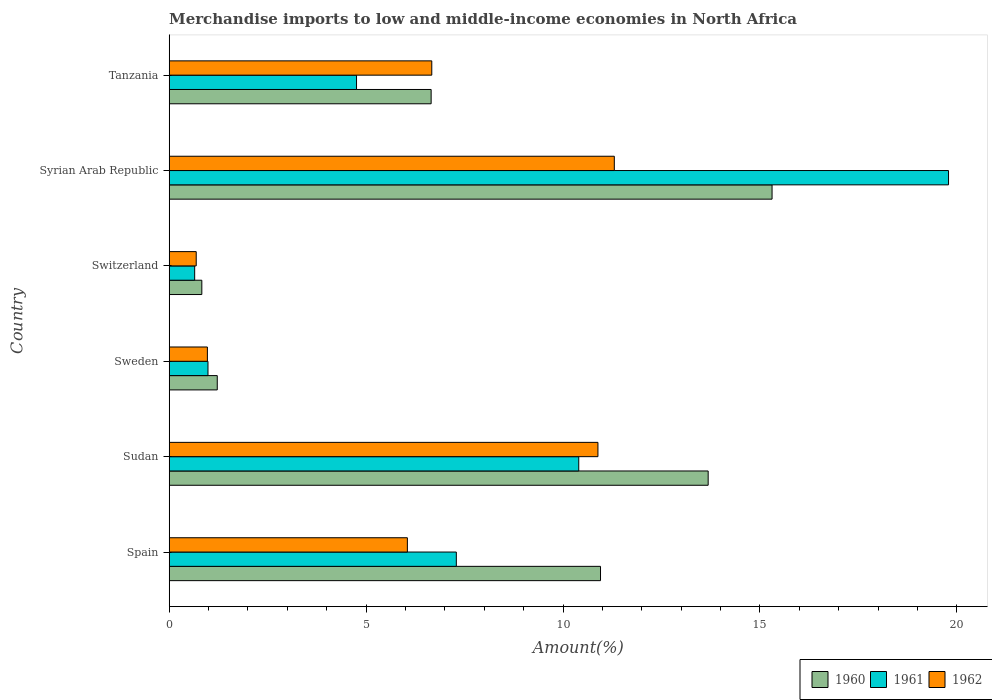How many different coloured bars are there?
Keep it short and to the point. 3. How many groups of bars are there?
Keep it short and to the point. 6. Are the number of bars on each tick of the Y-axis equal?
Provide a short and direct response. Yes. What is the label of the 4th group of bars from the top?
Provide a short and direct response. Sweden. In how many cases, is the number of bars for a given country not equal to the number of legend labels?
Give a very brief answer. 0. What is the percentage of amount earned from merchandise imports in 1960 in Spain?
Provide a short and direct response. 10.95. Across all countries, what is the maximum percentage of amount earned from merchandise imports in 1960?
Your answer should be very brief. 15.31. Across all countries, what is the minimum percentage of amount earned from merchandise imports in 1960?
Your response must be concise. 0.83. In which country was the percentage of amount earned from merchandise imports in 1962 maximum?
Offer a terse response. Syrian Arab Republic. In which country was the percentage of amount earned from merchandise imports in 1961 minimum?
Offer a very short reply. Switzerland. What is the total percentage of amount earned from merchandise imports in 1960 in the graph?
Your response must be concise. 48.64. What is the difference between the percentage of amount earned from merchandise imports in 1961 in Sweden and that in Tanzania?
Provide a short and direct response. -3.77. What is the difference between the percentage of amount earned from merchandise imports in 1960 in Spain and the percentage of amount earned from merchandise imports in 1961 in Tanzania?
Make the answer very short. 6.19. What is the average percentage of amount earned from merchandise imports in 1960 per country?
Your response must be concise. 8.11. What is the difference between the percentage of amount earned from merchandise imports in 1962 and percentage of amount earned from merchandise imports in 1960 in Sudan?
Give a very brief answer. -2.8. In how many countries, is the percentage of amount earned from merchandise imports in 1961 greater than 12 %?
Your answer should be very brief. 1. What is the ratio of the percentage of amount earned from merchandise imports in 1961 in Syrian Arab Republic to that in Tanzania?
Your answer should be very brief. 4.16. Is the percentage of amount earned from merchandise imports in 1961 in Spain less than that in Tanzania?
Your answer should be compact. No. Is the difference between the percentage of amount earned from merchandise imports in 1962 in Sudan and Switzerland greater than the difference between the percentage of amount earned from merchandise imports in 1960 in Sudan and Switzerland?
Keep it short and to the point. No. What is the difference between the highest and the second highest percentage of amount earned from merchandise imports in 1960?
Ensure brevity in your answer.  1.62. What is the difference between the highest and the lowest percentage of amount earned from merchandise imports in 1962?
Keep it short and to the point. 10.62. In how many countries, is the percentage of amount earned from merchandise imports in 1960 greater than the average percentage of amount earned from merchandise imports in 1960 taken over all countries?
Your answer should be very brief. 3. Is the sum of the percentage of amount earned from merchandise imports in 1962 in Switzerland and Syrian Arab Republic greater than the maximum percentage of amount earned from merchandise imports in 1961 across all countries?
Ensure brevity in your answer.  No. Is it the case that in every country, the sum of the percentage of amount earned from merchandise imports in 1962 and percentage of amount earned from merchandise imports in 1960 is greater than the percentage of amount earned from merchandise imports in 1961?
Offer a very short reply. Yes. What is the difference between two consecutive major ticks on the X-axis?
Your response must be concise. 5. Are the values on the major ticks of X-axis written in scientific E-notation?
Provide a succinct answer. No. Does the graph contain any zero values?
Make the answer very short. No. Does the graph contain grids?
Your answer should be compact. No. Where does the legend appear in the graph?
Your response must be concise. Bottom right. How are the legend labels stacked?
Your answer should be very brief. Horizontal. What is the title of the graph?
Offer a very short reply. Merchandise imports to low and middle-income economies in North Africa. What is the label or title of the X-axis?
Your response must be concise. Amount(%). What is the Amount(%) in 1960 in Spain?
Provide a short and direct response. 10.95. What is the Amount(%) in 1961 in Spain?
Your answer should be very brief. 7.29. What is the Amount(%) in 1962 in Spain?
Your response must be concise. 6.05. What is the Amount(%) of 1960 in Sudan?
Your answer should be very brief. 13.68. What is the Amount(%) in 1961 in Sudan?
Offer a very short reply. 10.4. What is the Amount(%) in 1962 in Sudan?
Your response must be concise. 10.89. What is the Amount(%) in 1960 in Sweden?
Your answer should be compact. 1.22. What is the Amount(%) of 1961 in Sweden?
Provide a succinct answer. 0.98. What is the Amount(%) in 1962 in Sweden?
Offer a terse response. 0.97. What is the Amount(%) of 1960 in Switzerland?
Provide a succinct answer. 0.83. What is the Amount(%) in 1961 in Switzerland?
Offer a terse response. 0.65. What is the Amount(%) in 1962 in Switzerland?
Offer a very short reply. 0.69. What is the Amount(%) of 1960 in Syrian Arab Republic?
Your response must be concise. 15.31. What is the Amount(%) in 1961 in Syrian Arab Republic?
Provide a short and direct response. 19.79. What is the Amount(%) in 1962 in Syrian Arab Republic?
Your response must be concise. 11.3. What is the Amount(%) in 1960 in Tanzania?
Your answer should be very brief. 6.65. What is the Amount(%) of 1961 in Tanzania?
Ensure brevity in your answer.  4.76. What is the Amount(%) in 1962 in Tanzania?
Give a very brief answer. 6.67. Across all countries, what is the maximum Amount(%) in 1960?
Your answer should be very brief. 15.31. Across all countries, what is the maximum Amount(%) of 1961?
Make the answer very short. 19.79. Across all countries, what is the maximum Amount(%) in 1962?
Offer a very short reply. 11.3. Across all countries, what is the minimum Amount(%) of 1960?
Ensure brevity in your answer.  0.83. Across all countries, what is the minimum Amount(%) of 1961?
Your response must be concise. 0.65. Across all countries, what is the minimum Amount(%) in 1962?
Your answer should be compact. 0.69. What is the total Amount(%) of 1960 in the graph?
Keep it short and to the point. 48.64. What is the total Amount(%) of 1961 in the graph?
Ensure brevity in your answer.  43.86. What is the total Amount(%) in 1962 in the graph?
Provide a short and direct response. 36.56. What is the difference between the Amount(%) of 1960 in Spain and that in Sudan?
Your answer should be very brief. -2.73. What is the difference between the Amount(%) in 1961 in Spain and that in Sudan?
Give a very brief answer. -3.11. What is the difference between the Amount(%) in 1962 in Spain and that in Sudan?
Your response must be concise. -4.84. What is the difference between the Amount(%) of 1960 in Spain and that in Sweden?
Offer a very short reply. 9.73. What is the difference between the Amount(%) in 1961 in Spain and that in Sweden?
Offer a very short reply. 6.31. What is the difference between the Amount(%) of 1962 in Spain and that in Sweden?
Your answer should be very brief. 5.08. What is the difference between the Amount(%) in 1960 in Spain and that in Switzerland?
Your answer should be very brief. 10.12. What is the difference between the Amount(%) of 1961 in Spain and that in Switzerland?
Provide a succinct answer. 6.64. What is the difference between the Amount(%) of 1962 in Spain and that in Switzerland?
Keep it short and to the point. 5.36. What is the difference between the Amount(%) in 1960 in Spain and that in Syrian Arab Republic?
Give a very brief answer. -4.36. What is the difference between the Amount(%) in 1961 in Spain and that in Syrian Arab Republic?
Provide a succinct answer. -12.5. What is the difference between the Amount(%) of 1962 in Spain and that in Syrian Arab Republic?
Offer a terse response. -5.25. What is the difference between the Amount(%) in 1960 in Spain and that in Tanzania?
Provide a short and direct response. 4.3. What is the difference between the Amount(%) of 1961 in Spain and that in Tanzania?
Your answer should be very brief. 2.53. What is the difference between the Amount(%) in 1962 in Spain and that in Tanzania?
Provide a short and direct response. -0.62. What is the difference between the Amount(%) of 1960 in Sudan and that in Sweden?
Offer a very short reply. 12.46. What is the difference between the Amount(%) in 1961 in Sudan and that in Sweden?
Keep it short and to the point. 9.41. What is the difference between the Amount(%) of 1962 in Sudan and that in Sweden?
Provide a succinct answer. 9.92. What is the difference between the Amount(%) of 1960 in Sudan and that in Switzerland?
Your answer should be very brief. 12.86. What is the difference between the Amount(%) in 1961 in Sudan and that in Switzerland?
Offer a very short reply. 9.75. What is the difference between the Amount(%) of 1962 in Sudan and that in Switzerland?
Your answer should be very brief. 10.2. What is the difference between the Amount(%) of 1960 in Sudan and that in Syrian Arab Republic?
Give a very brief answer. -1.62. What is the difference between the Amount(%) of 1961 in Sudan and that in Syrian Arab Republic?
Give a very brief answer. -9.39. What is the difference between the Amount(%) of 1962 in Sudan and that in Syrian Arab Republic?
Keep it short and to the point. -0.42. What is the difference between the Amount(%) in 1960 in Sudan and that in Tanzania?
Offer a very short reply. 7.03. What is the difference between the Amount(%) of 1961 in Sudan and that in Tanzania?
Your answer should be very brief. 5.64. What is the difference between the Amount(%) of 1962 in Sudan and that in Tanzania?
Your response must be concise. 4.22. What is the difference between the Amount(%) of 1960 in Sweden and that in Switzerland?
Make the answer very short. 0.39. What is the difference between the Amount(%) in 1961 in Sweden and that in Switzerland?
Keep it short and to the point. 0.34. What is the difference between the Amount(%) in 1962 in Sweden and that in Switzerland?
Offer a very short reply. 0.28. What is the difference between the Amount(%) of 1960 in Sweden and that in Syrian Arab Republic?
Provide a succinct answer. -14.09. What is the difference between the Amount(%) in 1961 in Sweden and that in Syrian Arab Republic?
Your response must be concise. -18.8. What is the difference between the Amount(%) of 1962 in Sweden and that in Syrian Arab Republic?
Ensure brevity in your answer.  -10.33. What is the difference between the Amount(%) in 1960 in Sweden and that in Tanzania?
Ensure brevity in your answer.  -5.43. What is the difference between the Amount(%) of 1961 in Sweden and that in Tanzania?
Provide a short and direct response. -3.77. What is the difference between the Amount(%) in 1962 in Sweden and that in Tanzania?
Keep it short and to the point. -5.7. What is the difference between the Amount(%) of 1960 in Switzerland and that in Syrian Arab Republic?
Provide a succinct answer. -14.48. What is the difference between the Amount(%) of 1961 in Switzerland and that in Syrian Arab Republic?
Ensure brevity in your answer.  -19.14. What is the difference between the Amount(%) in 1962 in Switzerland and that in Syrian Arab Republic?
Your answer should be very brief. -10.62. What is the difference between the Amount(%) of 1960 in Switzerland and that in Tanzania?
Provide a succinct answer. -5.82. What is the difference between the Amount(%) of 1961 in Switzerland and that in Tanzania?
Provide a succinct answer. -4.11. What is the difference between the Amount(%) of 1962 in Switzerland and that in Tanzania?
Offer a very short reply. -5.98. What is the difference between the Amount(%) of 1960 in Syrian Arab Republic and that in Tanzania?
Provide a short and direct response. 8.66. What is the difference between the Amount(%) in 1961 in Syrian Arab Republic and that in Tanzania?
Offer a terse response. 15.03. What is the difference between the Amount(%) in 1962 in Syrian Arab Republic and that in Tanzania?
Keep it short and to the point. 4.63. What is the difference between the Amount(%) in 1960 in Spain and the Amount(%) in 1961 in Sudan?
Ensure brevity in your answer.  0.55. What is the difference between the Amount(%) of 1960 in Spain and the Amount(%) of 1962 in Sudan?
Offer a terse response. 0.07. What is the difference between the Amount(%) in 1961 in Spain and the Amount(%) in 1962 in Sudan?
Provide a succinct answer. -3.6. What is the difference between the Amount(%) in 1960 in Spain and the Amount(%) in 1961 in Sweden?
Ensure brevity in your answer.  9.97. What is the difference between the Amount(%) of 1960 in Spain and the Amount(%) of 1962 in Sweden?
Give a very brief answer. 9.98. What is the difference between the Amount(%) of 1961 in Spain and the Amount(%) of 1962 in Sweden?
Keep it short and to the point. 6.32. What is the difference between the Amount(%) of 1960 in Spain and the Amount(%) of 1961 in Switzerland?
Provide a short and direct response. 10.3. What is the difference between the Amount(%) of 1960 in Spain and the Amount(%) of 1962 in Switzerland?
Ensure brevity in your answer.  10.27. What is the difference between the Amount(%) of 1961 in Spain and the Amount(%) of 1962 in Switzerland?
Offer a very short reply. 6.6. What is the difference between the Amount(%) of 1960 in Spain and the Amount(%) of 1961 in Syrian Arab Republic?
Your response must be concise. -8.84. What is the difference between the Amount(%) of 1960 in Spain and the Amount(%) of 1962 in Syrian Arab Republic?
Give a very brief answer. -0.35. What is the difference between the Amount(%) in 1961 in Spain and the Amount(%) in 1962 in Syrian Arab Republic?
Your answer should be very brief. -4.01. What is the difference between the Amount(%) in 1960 in Spain and the Amount(%) in 1961 in Tanzania?
Your answer should be compact. 6.19. What is the difference between the Amount(%) of 1960 in Spain and the Amount(%) of 1962 in Tanzania?
Ensure brevity in your answer.  4.28. What is the difference between the Amount(%) of 1961 in Spain and the Amount(%) of 1962 in Tanzania?
Offer a very short reply. 0.62. What is the difference between the Amount(%) in 1960 in Sudan and the Amount(%) in 1961 in Sweden?
Provide a short and direct response. 12.7. What is the difference between the Amount(%) in 1960 in Sudan and the Amount(%) in 1962 in Sweden?
Your response must be concise. 12.71. What is the difference between the Amount(%) in 1961 in Sudan and the Amount(%) in 1962 in Sweden?
Offer a terse response. 9.43. What is the difference between the Amount(%) in 1960 in Sudan and the Amount(%) in 1961 in Switzerland?
Your answer should be compact. 13.04. What is the difference between the Amount(%) in 1960 in Sudan and the Amount(%) in 1962 in Switzerland?
Give a very brief answer. 13. What is the difference between the Amount(%) in 1961 in Sudan and the Amount(%) in 1962 in Switzerland?
Offer a terse response. 9.71. What is the difference between the Amount(%) of 1960 in Sudan and the Amount(%) of 1961 in Syrian Arab Republic?
Your response must be concise. -6.1. What is the difference between the Amount(%) in 1960 in Sudan and the Amount(%) in 1962 in Syrian Arab Republic?
Make the answer very short. 2.38. What is the difference between the Amount(%) in 1961 in Sudan and the Amount(%) in 1962 in Syrian Arab Republic?
Offer a very short reply. -0.9. What is the difference between the Amount(%) in 1960 in Sudan and the Amount(%) in 1961 in Tanzania?
Your answer should be compact. 8.93. What is the difference between the Amount(%) in 1960 in Sudan and the Amount(%) in 1962 in Tanzania?
Provide a succinct answer. 7.02. What is the difference between the Amount(%) of 1961 in Sudan and the Amount(%) of 1962 in Tanzania?
Your answer should be very brief. 3.73. What is the difference between the Amount(%) in 1960 in Sweden and the Amount(%) in 1961 in Switzerland?
Ensure brevity in your answer.  0.57. What is the difference between the Amount(%) of 1960 in Sweden and the Amount(%) of 1962 in Switzerland?
Keep it short and to the point. 0.53. What is the difference between the Amount(%) of 1961 in Sweden and the Amount(%) of 1962 in Switzerland?
Offer a very short reply. 0.3. What is the difference between the Amount(%) in 1960 in Sweden and the Amount(%) in 1961 in Syrian Arab Republic?
Ensure brevity in your answer.  -18.57. What is the difference between the Amount(%) in 1960 in Sweden and the Amount(%) in 1962 in Syrian Arab Republic?
Ensure brevity in your answer.  -10.08. What is the difference between the Amount(%) of 1961 in Sweden and the Amount(%) of 1962 in Syrian Arab Republic?
Keep it short and to the point. -10.32. What is the difference between the Amount(%) of 1960 in Sweden and the Amount(%) of 1961 in Tanzania?
Keep it short and to the point. -3.54. What is the difference between the Amount(%) of 1960 in Sweden and the Amount(%) of 1962 in Tanzania?
Keep it short and to the point. -5.45. What is the difference between the Amount(%) of 1961 in Sweden and the Amount(%) of 1962 in Tanzania?
Your response must be concise. -5.68. What is the difference between the Amount(%) in 1960 in Switzerland and the Amount(%) in 1961 in Syrian Arab Republic?
Your answer should be compact. -18.96. What is the difference between the Amount(%) of 1960 in Switzerland and the Amount(%) of 1962 in Syrian Arab Republic?
Offer a terse response. -10.47. What is the difference between the Amount(%) of 1961 in Switzerland and the Amount(%) of 1962 in Syrian Arab Republic?
Keep it short and to the point. -10.65. What is the difference between the Amount(%) in 1960 in Switzerland and the Amount(%) in 1961 in Tanzania?
Ensure brevity in your answer.  -3.93. What is the difference between the Amount(%) of 1960 in Switzerland and the Amount(%) of 1962 in Tanzania?
Keep it short and to the point. -5.84. What is the difference between the Amount(%) of 1961 in Switzerland and the Amount(%) of 1962 in Tanzania?
Your answer should be very brief. -6.02. What is the difference between the Amount(%) of 1960 in Syrian Arab Republic and the Amount(%) of 1961 in Tanzania?
Make the answer very short. 10.55. What is the difference between the Amount(%) of 1960 in Syrian Arab Republic and the Amount(%) of 1962 in Tanzania?
Keep it short and to the point. 8.64. What is the difference between the Amount(%) in 1961 in Syrian Arab Republic and the Amount(%) in 1962 in Tanzania?
Ensure brevity in your answer.  13.12. What is the average Amount(%) in 1960 per country?
Your answer should be very brief. 8.11. What is the average Amount(%) in 1961 per country?
Offer a very short reply. 7.31. What is the average Amount(%) of 1962 per country?
Your response must be concise. 6.09. What is the difference between the Amount(%) of 1960 and Amount(%) of 1961 in Spain?
Your answer should be compact. 3.66. What is the difference between the Amount(%) in 1960 and Amount(%) in 1962 in Spain?
Offer a terse response. 4.9. What is the difference between the Amount(%) in 1961 and Amount(%) in 1962 in Spain?
Offer a very short reply. 1.24. What is the difference between the Amount(%) in 1960 and Amount(%) in 1961 in Sudan?
Your answer should be very brief. 3.29. What is the difference between the Amount(%) in 1960 and Amount(%) in 1962 in Sudan?
Give a very brief answer. 2.8. What is the difference between the Amount(%) in 1961 and Amount(%) in 1962 in Sudan?
Make the answer very short. -0.49. What is the difference between the Amount(%) in 1960 and Amount(%) in 1961 in Sweden?
Ensure brevity in your answer.  0.24. What is the difference between the Amount(%) in 1960 and Amount(%) in 1962 in Sweden?
Make the answer very short. 0.25. What is the difference between the Amount(%) in 1961 and Amount(%) in 1962 in Sweden?
Offer a terse response. 0.02. What is the difference between the Amount(%) of 1960 and Amount(%) of 1961 in Switzerland?
Your answer should be very brief. 0.18. What is the difference between the Amount(%) of 1960 and Amount(%) of 1962 in Switzerland?
Keep it short and to the point. 0.14. What is the difference between the Amount(%) of 1961 and Amount(%) of 1962 in Switzerland?
Your response must be concise. -0.04. What is the difference between the Amount(%) in 1960 and Amount(%) in 1961 in Syrian Arab Republic?
Provide a succinct answer. -4.48. What is the difference between the Amount(%) in 1960 and Amount(%) in 1962 in Syrian Arab Republic?
Make the answer very short. 4.01. What is the difference between the Amount(%) of 1961 and Amount(%) of 1962 in Syrian Arab Republic?
Offer a terse response. 8.49. What is the difference between the Amount(%) of 1960 and Amount(%) of 1961 in Tanzania?
Provide a short and direct response. 1.89. What is the difference between the Amount(%) of 1960 and Amount(%) of 1962 in Tanzania?
Make the answer very short. -0.02. What is the difference between the Amount(%) of 1961 and Amount(%) of 1962 in Tanzania?
Your answer should be compact. -1.91. What is the ratio of the Amount(%) in 1960 in Spain to that in Sudan?
Provide a succinct answer. 0.8. What is the ratio of the Amount(%) in 1961 in Spain to that in Sudan?
Provide a succinct answer. 0.7. What is the ratio of the Amount(%) in 1962 in Spain to that in Sudan?
Offer a very short reply. 0.56. What is the ratio of the Amount(%) of 1960 in Spain to that in Sweden?
Provide a succinct answer. 8.97. What is the ratio of the Amount(%) of 1961 in Spain to that in Sweden?
Keep it short and to the point. 7.4. What is the ratio of the Amount(%) in 1962 in Spain to that in Sweden?
Make the answer very short. 6.24. What is the ratio of the Amount(%) of 1960 in Spain to that in Switzerland?
Offer a terse response. 13.22. What is the ratio of the Amount(%) in 1961 in Spain to that in Switzerland?
Your answer should be compact. 11.28. What is the ratio of the Amount(%) of 1962 in Spain to that in Switzerland?
Your answer should be very brief. 8.82. What is the ratio of the Amount(%) in 1960 in Spain to that in Syrian Arab Republic?
Your response must be concise. 0.72. What is the ratio of the Amount(%) in 1961 in Spain to that in Syrian Arab Republic?
Keep it short and to the point. 0.37. What is the ratio of the Amount(%) in 1962 in Spain to that in Syrian Arab Republic?
Your answer should be compact. 0.54. What is the ratio of the Amount(%) in 1960 in Spain to that in Tanzania?
Give a very brief answer. 1.65. What is the ratio of the Amount(%) in 1961 in Spain to that in Tanzania?
Your answer should be very brief. 1.53. What is the ratio of the Amount(%) in 1962 in Spain to that in Tanzania?
Ensure brevity in your answer.  0.91. What is the ratio of the Amount(%) in 1960 in Sudan to that in Sweden?
Ensure brevity in your answer.  11.21. What is the ratio of the Amount(%) of 1961 in Sudan to that in Sweden?
Your response must be concise. 10.56. What is the ratio of the Amount(%) of 1962 in Sudan to that in Sweden?
Provide a short and direct response. 11.23. What is the ratio of the Amount(%) of 1960 in Sudan to that in Switzerland?
Your answer should be very brief. 16.52. What is the ratio of the Amount(%) in 1961 in Sudan to that in Switzerland?
Offer a very short reply. 16.08. What is the ratio of the Amount(%) of 1962 in Sudan to that in Switzerland?
Your answer should be compact. 15.87. What is the ratio of the Amount(%) in 1960 in Sudan to that in Syrian Arab Republic?
Your answer should be compact. 0.89. What is the ratio of the Amount(%) of 1961 in Sudan to that in Syrian Arab Republic?
Ensure brevity in your answer.  0.53. What is the ratio of the Amount(%) of 1962 in Sudan to that in Syrian Arab Republic?
Make the answer very short. 0.96. What is the ratio of the Amount(%) in 1960 in Sudan to that in Tanzania?
Your response must be concise. 2.06. What is the ratio of the Amount(%) in 1961 in Sudan to that in Tanzania?
Give a very brief answer. 2.19. What is the ratio of the Amount(%) of 1962 in Sudan to that in Tanzania?
Your response must be concise. 1.63. What is the ratio of the Amount(%) of 1960 in Sweden to that in Switzerland?
Offer a terse response. 1.47. What is the ratio of the Amount(%) in 1961 in Sweden to that in Switzerland?
Offer a very short reply. 1.52. What is the ratio of the Amount(%) in 1962 in Sweden to that in Switzerland?
Keep it short and to the point. 1.41. What is the ratio of the Amount(%) of 1960 in Sweden to that in Syrian Arab Republic?
Your answer should be very brief. 0.08. What is the ratio of the Amount(%) of 1961 in Sweden to that in Syrian Arab Republic?
Ensure brevity in your answer.  0.05. What is the ratio of the Amount(%) of 1962 in Sweden to that in Syrian Arab Republic?
Give a very brief answer. 0.09. What is the ratio of the Amount(%) in 1960 in Sweden to that in Tanzania?
Provide a short and direct response. 0.18. What is the ratio of the Amount(%) of 1961 in Sweden to that in Tanzania?
Your answer should be very brief. 0.21. What is the ratio of the Amount(%) of 1962 in Sweden to that in Tanzania?
Offer a very short reply. 0.15. What is the ratio of the Amount(%) of 1960 in Switzerland to that in Syrian Arab Republic?
Make the answer very short. 0.05. What is the ratio of the Amount(%) in 1961 in Switzerland to that in Syrian Arab Republic?
Keep it short and to the point. 0.03. What is the ratio of the Amount(%) of 1962 in Switzerland to that in Syrian Arab Republic?
Provide a short and direct response. 0.06. What is the ratio of the Amount(%) in 1960 in Switzerland to that in Tanzania?
Ensure brevity in your answer.  0.12. What is the ratio of the Amount(%) in 1961 in Switzerland to that in Tanzania?
Your answer should be very brief. 0.14. What is the ratio of the Amount(%) of 1962 in Switzerland to that in Tanzania?
Your response must be concise. 0.1. What is the ratio of the Amount(%) in 1960 in Syrian Arab Republic to that in Tanzania?
Make the answer very short. 2.3. What is the ratio of the Amount(%) of 1961 in Syrian Arab Republic to that in Tanzania?
Provide a short and direct response. 4.16. What is the ratio of the Amount(%) of 1962 in Syrian Arab Republic to that in Tanzania?
Your answer should be very brief. 1.7. What is the difference between the highest and the second highest Amount(%) in 1960?
Keep it short and to the point. 1.62. What is the difference between the highest and the second highest Amount(%) in 1961?
Provide a succinct answer. 9.39. What is the difference between the highest and the second highest Amount(%) in 1962?
Offer a very short reply. 0.42. What is the difference between the highest and the lowest Amount(%) in 1960?
Your answer should be very brief. 14.48. What is the difference between the highest and the lowest Amount(%) in 1961?
Offer a very short reply. 19.14. What is the difference between the highest and the lowest Amount(%) of 1962?
Offer a very short reply. 10.62. 